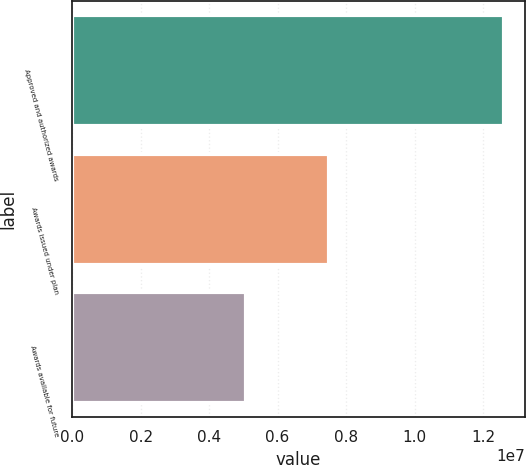Convert chart to OTSL. <chart><loc_0><loc_0><loc_500><loc_500><bar_chart><fcel>Approved and authorized awards<fcel>Awards issued under plan<fcel>Awards available for future<nl><fcel>1.26e+07<fcel>7.50935e+06<fcel>5.09065e+06<nl></chart> 